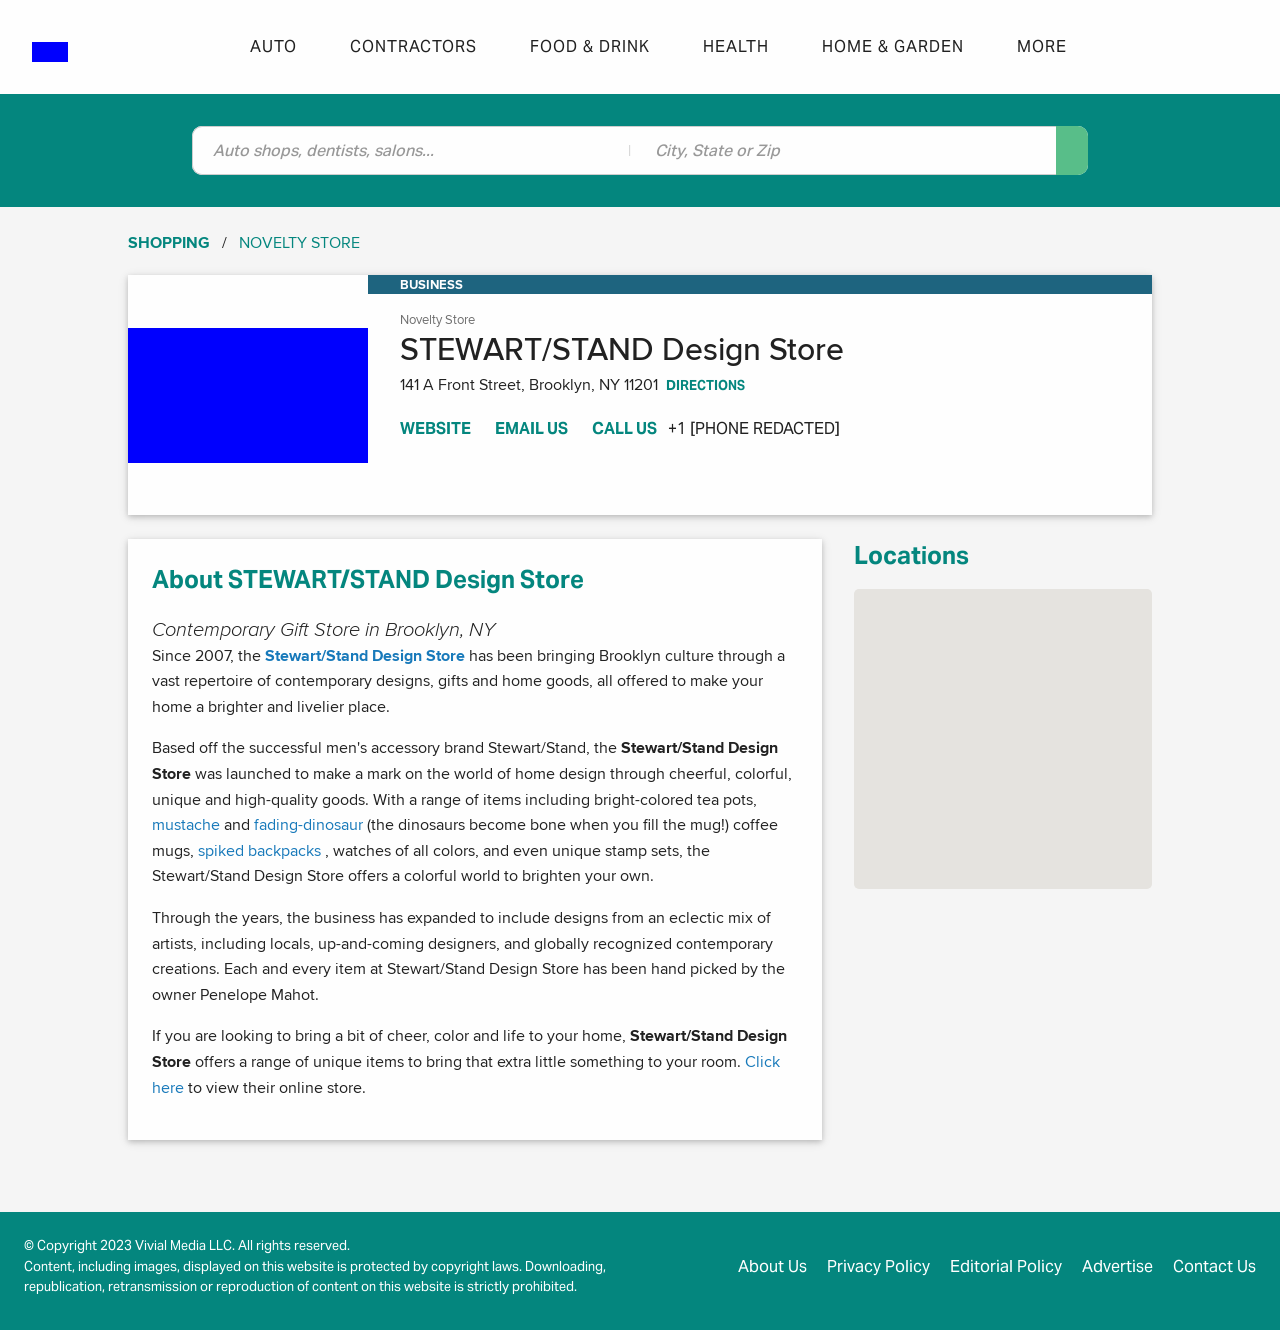What are some of the design influences for the products at STEWART/STAND Design Store? The product designs at STEWART/STAND Design Store are influenced by a range of factors including contemporary art, modern design trends, and functionality. The store collaborates with local artists and designers to bring in fresh, innovative ideas that often reflect the cultural vibrancy of Brooklyn.  How does STEWART/STAND Design Store contribute to the local community or art scene? STEWART/STAND Design Store contributes to the local community and art scene by promoting local artists and designers, providing them a platform to showcase their work. The store hosts events, collaborates on exclusive designs, and fosters a community-focused atmosphere that celebrates and supports local talent and creativity. 